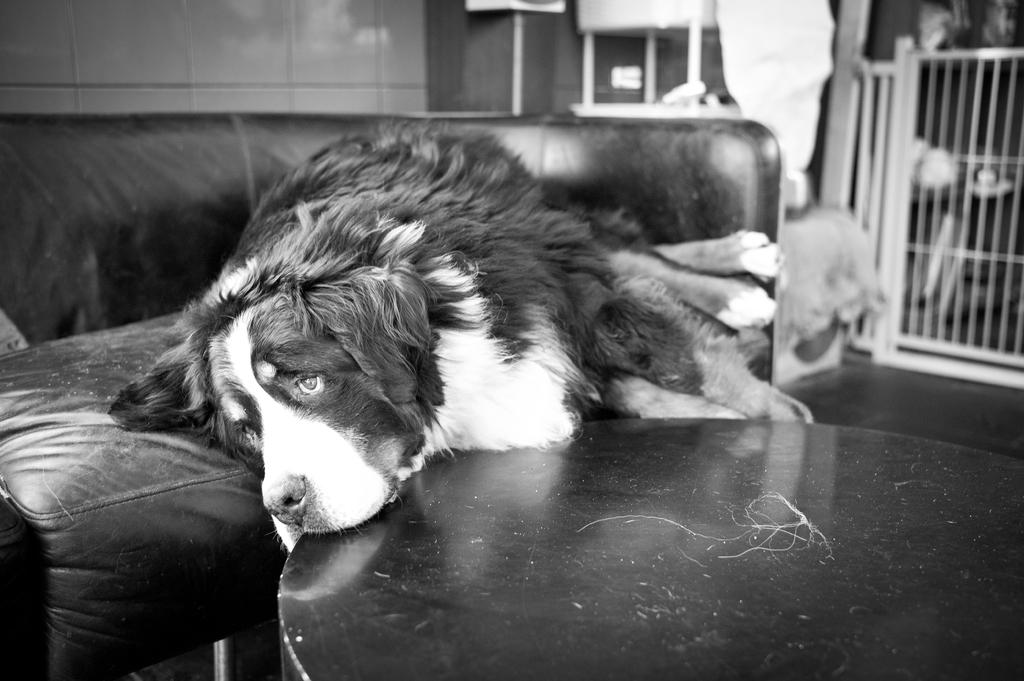What is the color scheme of the image? The image is black and white. What animal can be seen in the image? There is a dog in the image. Where is the dog positioned in the image? The dog is lying on a sofa and has its head on a table. What can be seen in the background of the image? There is a wall and a fence in the background of the image, along with other items. How many babies are participating in the competition in the image? There are no babies or competitions present in the image; it features a dog lying on a sofa with its head on a table. 